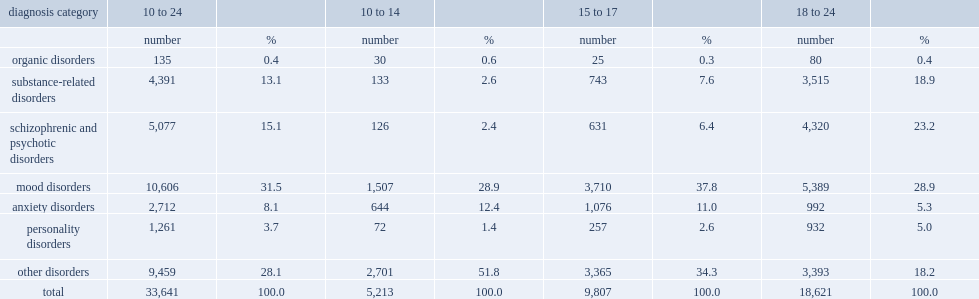List the diagnosis category which were the most common among 18- to 24-year-olds. Mood disorders. 